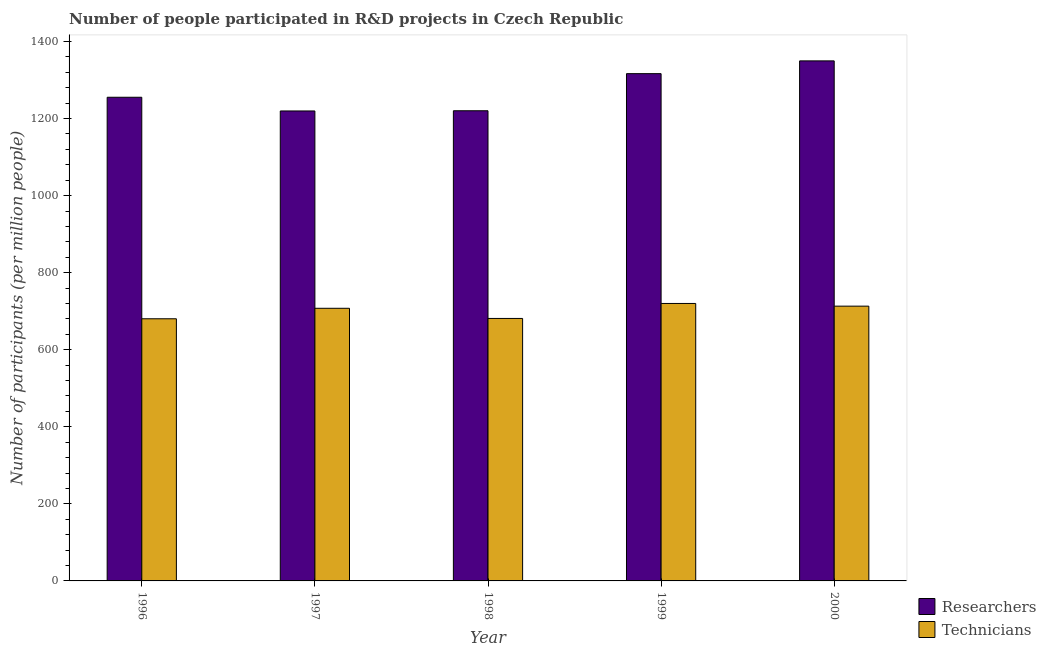How many groups of bars are there?
Provide a succinct answer. 5. Are the number of bars per tick equal to the number of legend labels?
Ensure brevity in your answer.  Yes. How many bars are there on the 2nd tick from the left?
Your answer should be compact. 2. How many bars are there on the 3rd tick from the right?
Your answer should be very brief. 2. In how many cases, is the number of bars for a given year not equal to the number of legend labels?
Provide a succinct answer. 0. What is the number of technicians in 1999?
Make the answer very short. 720.1. Across all years, what is the maximum number of researchers?
Your answer should be compact. 1349.7. Across all years, what is the minimum number of technicians?
Your answer should be compact. 680.37. In which year was the number of technicians maximum?
Provide a succinct answer. 1999. In which year was the number of technicians minimum?
Your answer should be very brief. 1996. What is the total number of technicians in the graph?
Give a very brief answer. 3502.41. What is the difference between the number of technicians in 1997 and that in 2000?
Your answer should be compact. -5.55. What is the difference between the number of technicians in 2000 and the number of researchers in 1999?
Offer a very short reply. -6.96. What is the average number of technicians per year?
Your answer should be very brief. 700.48. What is the ratio of the number of technicians in 1996 to that in 1998?
Give a very brief answer. 1. Is the difference between the number of researchers in 1999 and 2000 greater than the difference between the number of technicians in 1999 and 2000?
Offer a very short reply. No. What is the difference between the highest and the second highest number of researchers?
Provide a short and direct response. 33.13. What is the difference between the highest and the lowest number of researchers?
Your answer should be very brief. 129.98. What does the 1st bar from the left in 1997 represents?
Keep it short and to the point. Researchers. What does the 2nd bar from the right in 1999 represents?
Ensure brevity in your answer.  Researchers. How many bars are there?
Provide a succinct answer. 10. What is the difference between two consecutive major ticks on the Y-axis?
Provide a short and direct response. 200. Are the values on the major ticks of Y-axis written in scientific E-notation?
Your response must be concise. No. How many legend labels are there?
Offer a terse response. 2. How are the legend labels stacked?
Offer a very short reply. Vertical. What is the title of the graph?
Offer a terse response. Number of people participated in R&D projects in Czech Republic. What is the label or title of the Y-axis?
Keep it short and to the point. Number of participants (per million people). What is the Number of participants (per million people) of Researchers in 1996?
Ensure brevity in your answer.  1255.29. What is the Number of participants (per million people) in Technicians in 1996?
Keep it short and to the point. 680.37. What is the Number of participants (per million people) of Researchers in 1997?
Make the answer very short. 1219.72. What is the Number of participants (per million people) in Technicians in 1997?
Provide a succinct answer. 707.59. What is the Number of participants (per million people) in Researchers in 1998?
Your response must be concise. 1220.24. What is the Number of participants (per million people) of Technicians in 1998?
Your answer should be compact. 681.2. What is the Number of participants (per million people) of Researchers in 1999?
Offer a terse response. 1316.57. What is the Number of participants (per million people) in Technicians in 1999?
Ensure brevity in your answer.  720.1. What is the Number of participants (per million people) of Researchers in 2000?
Your response must be concise. 1349.7. What is the Number of participants (per million people) of Technicians in 2000?
Make the answer very short. 713.14. Across all years, what is the maximum Number of participants (per million people) of Researchers?
Make the answer very short. 1349.7. Across all years, what is the maximum Number of participants (per million people) of Technicians?
Offer a very short reply. 720.1. Across all years, what is the minimum Number of participants (per million people) in Researchers?
Make the answer very short. 1219.72. Across all years, what is the minimum Number of participants (per million people) in Technicians?
Make the answer very short. 680.37. What is the total Number of participants (per million people) in Researchers in the graph?
Your answer should be very brief. 6361.52. What is the total Number of participants (per million people) of Technicians in the graph?
Provide a short and direct response. 3502.41. What is the difference between the Number of participants (per million people) of Researchers in 1996 and that in 1997?
Your answer should be compact. 35.57. What is the difference between the Number of participants (per million people) in Technicians in 1996 and that in 1997?
Your response must be concise. -27.22. What is the difference between the Number of participants (per million people) in Researchers in 1996 and that in 1998?
Make the answer very short. 35.05. What is the difference between the Number of participants (per million people) of Technicians in 1996 and that in 1998?
Ensure brevity in your answer.  -0.83. What is the difference between the Number of participants (per million people) of Researchers in 1996 and that in 1999?
Your response must be concise. -61.28. What is the difference between the Number of participants (per million people) in Technicians in 1996 and that in 1999?
Your response must be concise. -39.73. What is the difference between the Number of participants (per million people) in Researchers in 1996 and that in 2000?
Provide a short and direct response. -94.41. What is the difference between the Number of participants (per million people) in Technicians in 1996 and that in 2000?
Your response must be concise. -32.77. What is the difference between the Number of participants (per million people) of Researchers in 1997 and that in 1998?
Your answer should be compact. -0.52. What is the difference between the Number of participants (per million people) in Technicians in 1997 and that in 1998?
Offer a very short reply. 26.39. What is the difference between the Number of participants (per million people) in Researchers in 1997 and that in 1999?
Offer a very short reply. -96.85. What is the difference between the Number of participants (per million people) in Technicians in 1997 and that in 1999?
Offer a terse response. -12.51. What is the difference between the Number of participants (per million people) in Researchers in 1997 and that in 2000?
Give a very brief answer. -129.98. What is the difference between the Number of participants (per million people) in Technicians in 1997 and that in 2000?
Provide a short and direct response. -5.55. What is the difference between the Number of participants (per million people) of Researchers in 1998 and that in 1999?
Your answer should be very brief. -96.33. What is the difference between the Number of participants (per million people) in Technicians in 1998 and that in 1999?
Your answer should be compact. -38.9. What is the difference between the Number of participants (per million people) of Researchers in 1998 and that in 2000?
Make the answer very short. -129.46. What is the difference between the Number of participants (per million people) of Technicians in 1998 and that in 2000?
Give a very brief answer. -31.94. What is the difference between the Number of participants (per million people) of Researchers in 1999 and that in 2000?
Give a very brief answer. -33.13. What is the difference between the Number of participants (per million people) of Technicians in 1999 and that in 2000?
Ensure brevity in your answer.  6.96. What is the difference between the Number of participants (per million people) of Researchers in 1996 and the Number of participants (per million people) of Technicians in 1997?
Your response must be concise. 547.7. What is the difference between the Number of participants (per million people) in Researchers in 1996 and the Number of participants (per million people) in Technicians in 1998?
Offer a very short reply. 574.09. What is the difference between the Number of participants (per million people) of Researchers in 1996 and the Number of participants (per million people) of Technicians in 1999?
Your answer should be very brief. 535.19. What is the difference between the Number of participants (per million people) of Researchers in 1996 and the Number of participants (per million people) of Technicians in 2000?
Your answer should be very brief. 542.15. What is the difference between the Number of participants (per million people) of Researchers in 1997 and the Number of participants (per million people) of Technicians in 1998?
Provide a short and direct response. 538.52. What is the difference between the Number of participants (per million people) in Researchers in 1997 and the Number of participants (per million people) in Technicians in 1999?
Keep it short and to the point. 499.62. What is the difference between the Number of participants (per million people) in Researchers in 1997 and the Number of participants (per million people) in Technicians in 2000?
Your answer should be very brief. 506.58. What is the difference between the Number of participants (per million people) of Researchers in 1998 and the Number of participants (per million people) of Technicians in 1999?
Offer a terse response. 500.14. What is the difference between the Number of participants (per million people) in Researchers in 1998 and the Number of participants (per million people) in Technicians in 2000?
Your response must be concise. 507.1. What is the difference between the Number of participants (per million people) of Researchers in 1999 and the Number of participants (per million people) of Technicians in 2000?
Ensure brevity in your answer.  603.42. What is the average Number of participants (per million people) in Researchers per year?
Offer a very short reply. 1272.3. What is the average Number of participants (per million people) in Technicians per year?
Offer a very short reply. 700.48. In the year 1996, what is the difference between the Number of participants (per million people) of Researchers and Number of participants (per million people) of Technicians?
Provide a succinct answer. 574.92. In the year 1997, what is the difference between the Number of participants (per million people) of Researchers and Number of participants (per million people) of Technicians?
Your response must be concise. 512.13. In the year 1998, what is the difference between the Number of participants (per million people) of Researchers and Number of participants (per million people) of Technicians?
Provide a short and direct response. 539.04. In the year 1999, what is the difference between the Number of participants (per million people) in Researchers and Number of participants (per million people) in Technicians?
Offer a very short reply. 596.47. In the year 2000, what is the difference between the Number of participants (per million people) in Researchers and Number of participants (per million people) in Technicians?
Make the answer very short. 636.56. What is the ratio of the Number of participants (per million people) of Researchers in 1996 to that in 1997?
Provide a short and direct response. 1.03. What is the ratio of the Number of participants (per million people) in Technicians in 1996 to that in 1997?
Offer a terse response. 0.96. What is the ratio of the Number of participants (per million people) of Researchers in 1996 to that in 1998?
Ensure brevity in your answer.  1.03. What is the ratio of the Number of participants (per million people) of Technicians in 1996 to that in 1998?
Keep it short and to the point. 1. What is the ratio of the Number of participants (per million people) of Researchers in 1996 to that in 1999?
Offer a very short reply. 0.95. What is the ratio of the Number of participants (per million people) of Technicians in 1996 to that in 1999?
Provide a short and direct response. 0.94. What is the ratio of the Number of participants (per million people) of Researchers in 1996 to that in 2000?
Provide a succinct answer. 0.93. What is the ratio of the Number of participants (per million people) of Technicians in 1996 to that in 2000?
Make the answer very short. 0.95. What is the ratio of the Number of participants (per million people) in Technicians in 1997 to that in 1998?
Give a very brief answer. 1.04. What is the ratio of the Number of participants (per million people) of Researchers in 1997 to that in 1999?
Offer a very short reply. 0.93. What is the ratio of the Number of participants (per million people) in Technicians in 1997 to that in 1999?
Your answer should be very brief. 0.98. What is the ratio of the Number of participants (per million people) of Researchers in 1997 to that in 2000?
Keep it short and to the point. 0.9. What is the ratio of the Number of participants (per million people) of Technicians in 1997 to that in 2000?
Your answer should be compact. 0.99. What is the ratio of the Number of participants (per million people) of Researchers in 1998 to that in 1999?
Provide a short and direct response. 0.93. What is the ratio of the Number of participants (per million people) in Technicians in 1998 to that in 1999?
Give a very brief answer. 0.95. What is the ratio of the Number of participants (per million people) of Researchers in 1998 to that in 2000?
Your answer should be compact. 0.9. What is the ratio of the Number of participants (per million people) of Technicians in 1998 to that in 2000?
Your answer should be very brief. 0.96. What is the ratio of the Number of participants (per million people) in Researchers in 1999 to that in 2000?
Make the answer very short. 0.98. What is the ratio of the Number of participants (per million people) of Technicians in 1999 to that in 2000?
Provide a short and direct response. 1.01. What is the difference between the highest and the second highest Number of participants (per million people) of Researchers?
Your response must be concise. 33.13. What is the difference between the highest and the second highest Number of participants (per million people) of Technicians?
Provide a short and direct response. 6.96. What is the difference between the highest and the lowest Number of participants (per million people) in Researchers?
Your answer should be very brief. 129.98. What is the difference between the highest and the lowest Number of participants (per million people) of Technicians?
Keep it short and to the point. 39.73. 